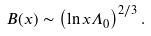<formula> <loc_0><loc_0><loc_500><loc_500>B ( x ) \sim \left ( \ln x \Lambda _ { 0 } \right ) ^ { 2 / 3 } .</formula> 